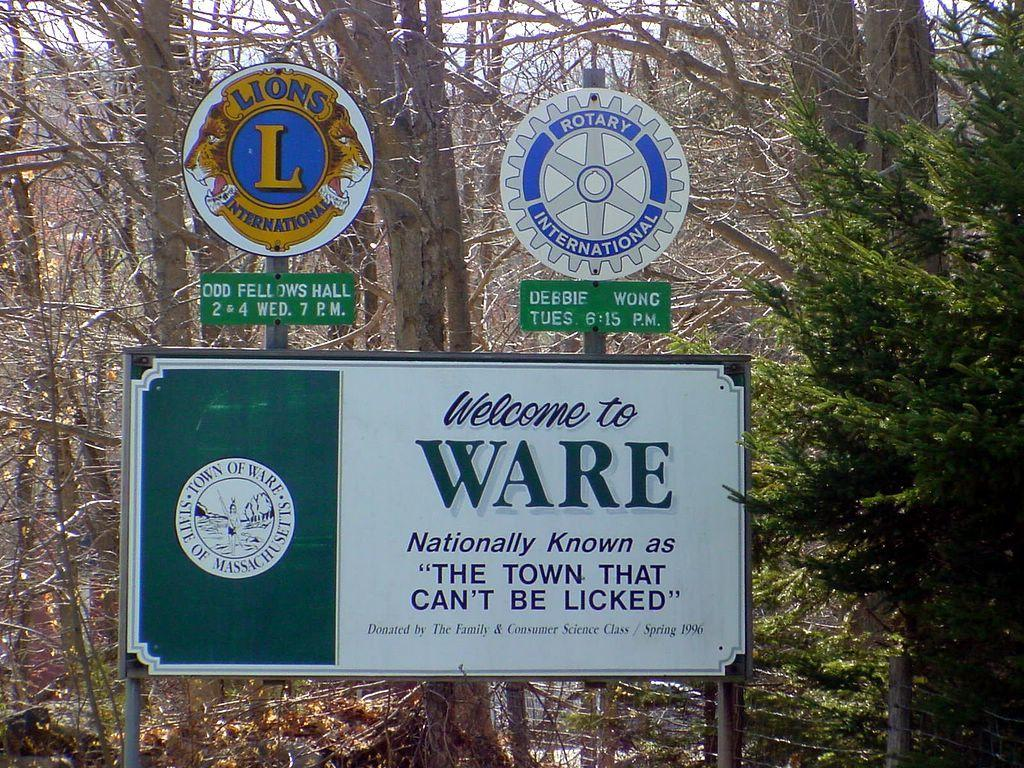<image>
Share a concise interpretation of the image provided. White and green sign which says "Welcome to Ware". 